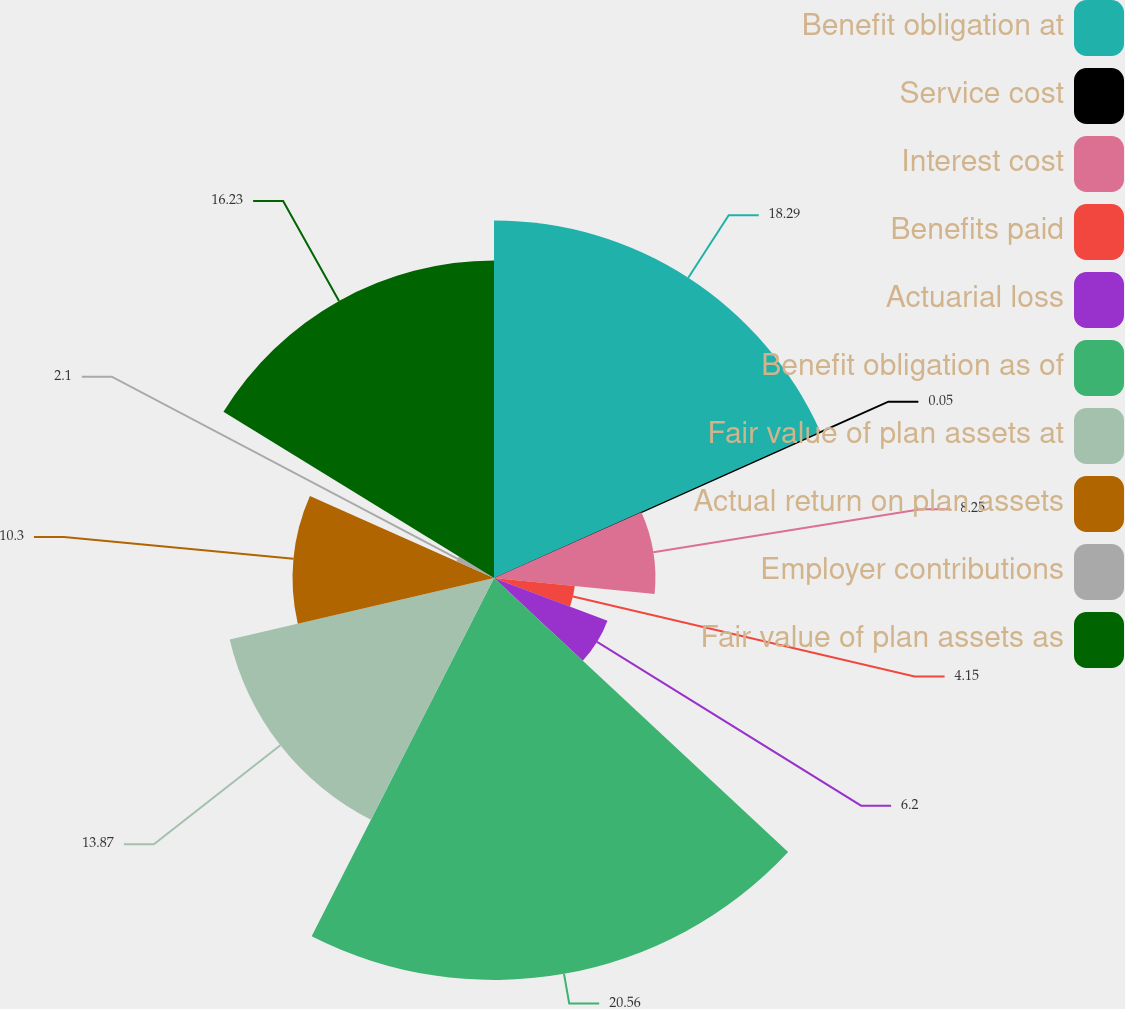<chart> <loc_0><loc_0><loc_500><loc_500><pie_chart><fcel>Benefit obligation at<fcel>Service cost<fcel>Interest cost<fcel>Benefits paid<fcel>Actuarial loss<fcel>Benefit obligation as of<fcel>Fair value of plan assets at<fcel>Actual return on plan assets<fcel>Employer contributions<fcel>Fair value of plan assets as<nl><fcel>18.28%<fcel>0.05%<fcel>8.25%<fcel>4.15%<fcel>6.2%<fcel>20.55%<fcel>13.87%<fcel>10.3%<fcel>2.1%<fcel>16.23%<nl></chart> 